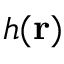<formula> <loc_0><loc_0><loc_500><loc_500>h ( r )</formula> 